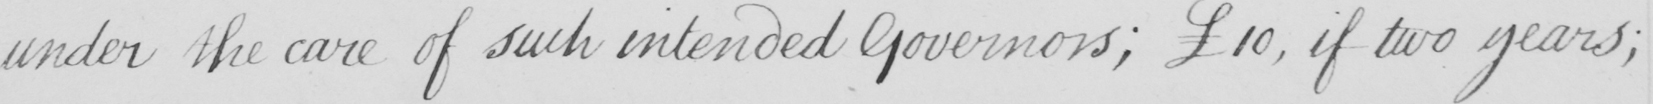What does this handwritten line say? under the care of such intended Governors ; £10 , if two years ; 